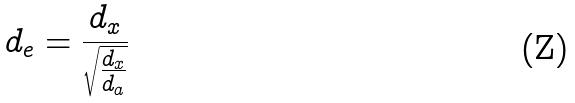Convert formula to latex. <formula><loc_0><loc_0><loc_500><loc_500>d _ { e } = \frac { d _ { x } } { \sqrt { \frac { d _ { x } } { d _ { a } } } }</formula> 